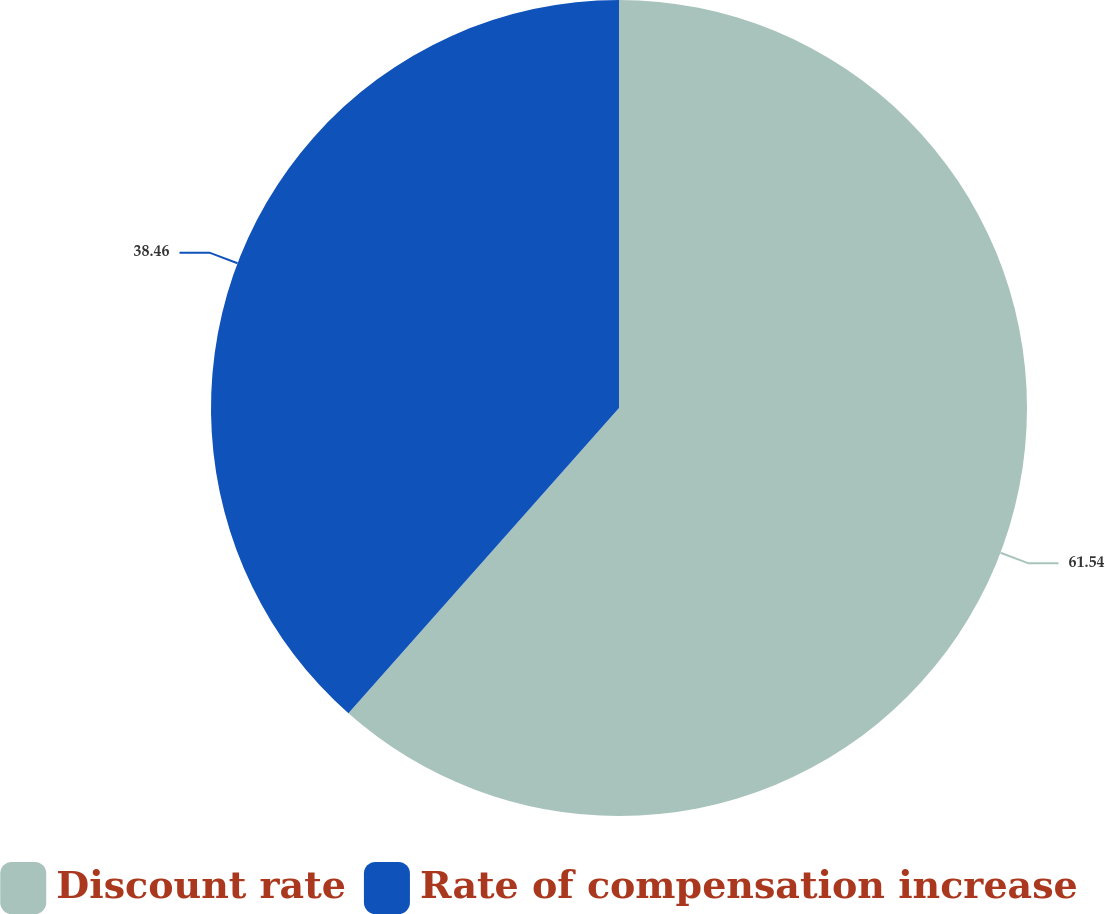Convert chart to OTSL. <chart><loc_0><loc_0><loc_500><loc_500><pie_chart><fcel>Discount rate<fcel>Rate of compensation increase<nl><fcel>61.54%<fcel>38.46%<nl></chart> 